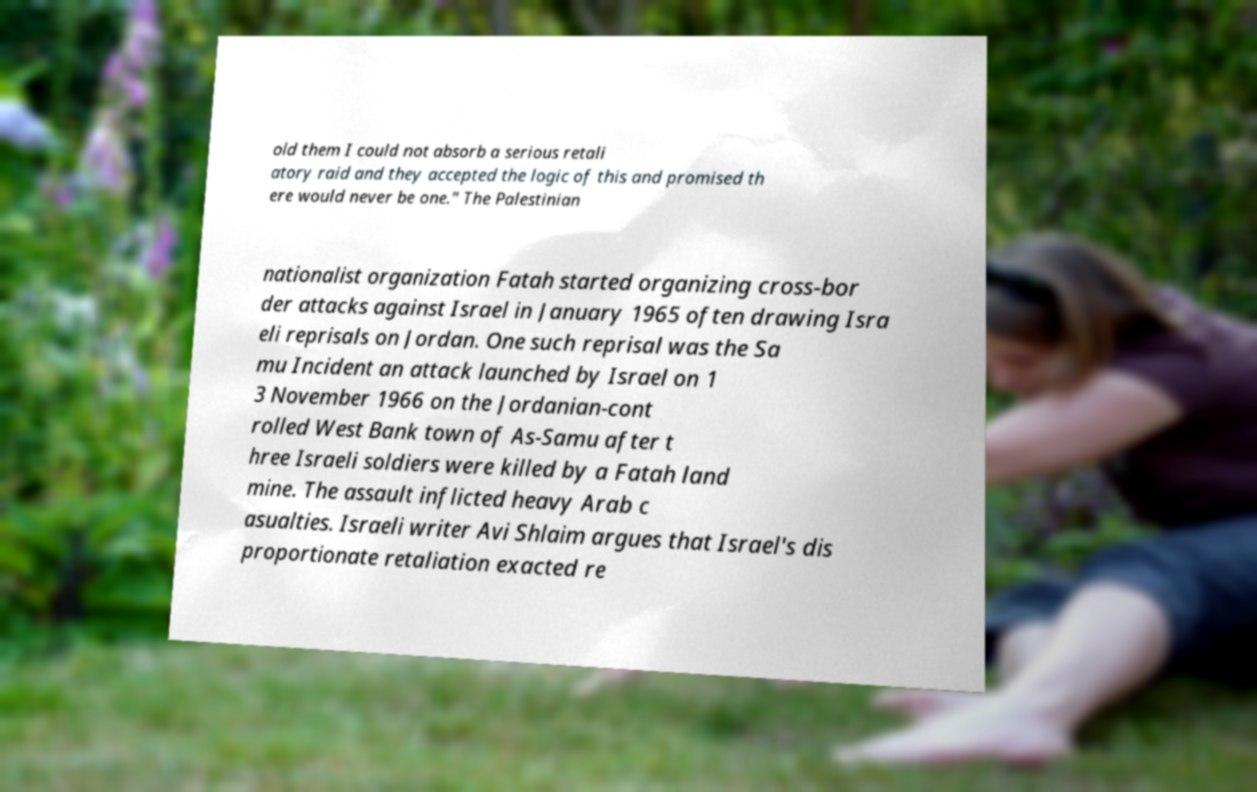For documentation purposes, I need the text within this image transcribed. Could you provide that? old them I could not absorb a serious retali atory raid and they accepted the logic of this and promised th ere would never be one." The Palestinian nationalist organization Fatah started organizing cross-bor der attacks against Israel in January 1965 often drawing Isra eli reprisals on Jordan. One such reprisal was the Sa mu Incident an attack launched by Israel on 1 3 November 1966 on the Jordanian-cont rolled West Bank town of As-Samu after t hree Israeli soldiers were killed by a Fatah land mine. The assault inflicted heavy Arab c asualties. Israeli writer Avi Shlaim argues that Israel's dis proportionate retaliation exacted re 